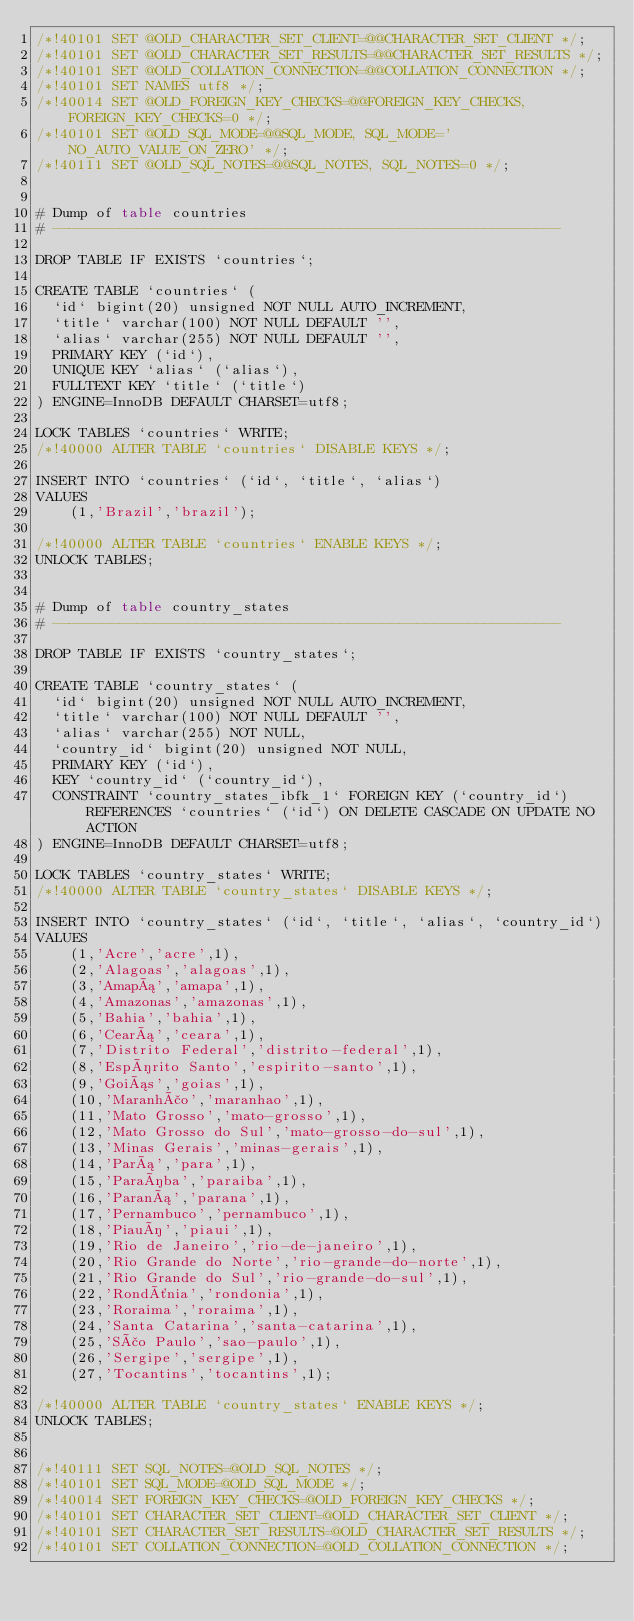<code> <loc_0><loc_0><loc_500><loc_500><_SQL_>/*!40101 SET @OLD_CHARACTER_SET_CLIENT=@@CHARACTER_SET_CLIENT */;
/*!40101 SET @OLD_CHARACTER_SET_RESULTS=@@CHARACTER_SET_RESULTS */;
/*!40101 SET @OLD_COLLATION_CONNECTION=@@COLLATION_CONNECTION */;
/*!40101 SET NAMES utf8 */;
/*!40014 SET @OLD_FOREIGN_KEY_CHECKS=@@FOREIGN_KEY_CHECKS, FOREIGN_KEY_CHECKS=0 */;
/*!40101 SET @OLD_SQL_MODE=@@SQL_MODE, SQL_MODE='NO_AUTO_VALUE_ON_ZERO' */;
/*!40111 SET @OLD_SQL_NOTES=@@SQL_NOTES, SQL_NOTES=0 */;


# Dump of table countries
# ------------------------------------------------------------

DROP TABLE IF EXISTS `countries`;

CREATE TABLE `countries` (
  `id` bigint(20) unsigned NOT NULL AUTO_INCREMENT,
  `title` varchar(100) NOT NULL DEFAULT '',
  `alias` varchar(255) NOT NULL DEFAULT '',
  PRIMARY KEY (`id`),
  UNIQUE KEY `alias` (`alias`),
  FULLTEXT KEY `title` (`title`)
) ENGINE=InnoDB DEFAULT CHARSET=utf8;

LOCK TABLES `countries` WRITE;
/*!40000 ALTER TABLE `countries` DISABLE KEYS */;

INSERT INTO `countries` (`id`, `title`, `alias`)
VALUES
	(1,'Brazil','brazil');

/*!40000 ALTER TABLE `countries` ENABLE KEYS */;
UNLOCK TABLES;


# Dump of table country_states
# ------------------------------------------------------------

DROP TABLE IF EXISTS `country_states`;

CREATE TABLE `country_states` (
  `id` bigint(20) unsigned NOT NULL AUTO_INCREMENT,
  `title` varchar(100) NOT NULL DEFAULT '',
  `alias` varchar(255) NOT NULL,
  `country_id` bigint(20) unsigned NOT NULL,
  PRIMARY KEY (`id`),
  KEY `country_id` (`country_id`),
  CONSTRAINT `country_states_ibfk_1` FOREIGN KEY (`country_id`) REFERENCES `countries` (`id`) ON DELETE CASCADE ON UPDATE NO ACTION
) ENGINE=InnoDB DEFAULT CHARSET=utf8;

LOCK TABLES `country_states` WRITE;
/*!40000 ALTER TABLE `country_states` DISABLE KEYS */;

INSERT INTO `country_states` (`id`, `title`, `alias`, `country_id`)
VALUES
	(1,'Acre','acre',1),
	(2,'Alagoas','alagoas',1),
	(3,'Amapá','amapa',1),
	(4,'Amazonas','amazonas',1),
	(5,'Bahia','bahia',1),
	(6,'Ceará','ceara',1),
	(7,'Distrito Federal','distrito-federal',1),
	(8,'Espírito Santo','espirito-santo',1),
	(9,'Goiás','goias',1),
	(10,'Maranhão','maranhao',1),
	(11,'Mato Grosso','mato-grosso',1),
	(12,'Mato Grosso do Sul','mato-grosso-do-sul',1),
	(13,'Minas Gerais','minas-gerais',1),
	(14,'Pará','para',1),
	(15,'Paraíba','paraiba',1),
	(16,'Paraná','parana',1),
	(17,'Pernambuco','pernambuco',1),
	(18,'Piauí','piaui',1),
	(19,'Rio de Janeiro','rio-de-janeiro',1),
	(20,'Rio Grande do Norte','rio-grande-do-norte',1),
	(21,'Rio Grande do Sul','rio-grande-do-sul',1),
	(22,'Rondônia','rondonia',1),
	(23,'Roraima','roraima',1),
	(24,'Santa Catarina','santa-catarina',1),
	(25,'São Paulo','sao-paulo',1),
	(26,'Sergipe','sergipe',1),
	(27,'Tocantins','tocantins',1);

/*!40000 ALTER TABLE `country_states` ENABLE KEYS */;
UNLOCK TABLES;


/*!40111 SET SQL_NOTES=@OLD_SQL_NOTES */;
/*!40101 SET SQL_MODE=@OLD_SQL_MODE */;
/*!40014 SET FOREIGN_KEY_CHECKS=@OLD_FOREIGN_KEY_CHECKS */;
/*!40101 SET CHARACTER_SET_CLIENT=@OLD_CHARACTER_SET_CLIENT */;
/*!40101 SET CHARACTER_SET_RESULTS=@OLD_CHARACTER_SET_RESULTS */;
/*!40101 SET COLLATION_CONNECTION=@OLD_COLLATION_CONNECTION */;
</code> 